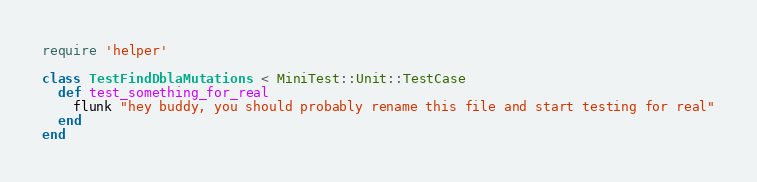Convert code to text. <code><loc_0><loc_0><loc_500><loc_500><_Ruby_>require 'helper'

class TestFindDblaMutations < MiniTest::Unit::TestCase
  def test_something_for_real
    flunk "hey buddy, you should probably rename this file and start testing for real"
  end
end
</code> 